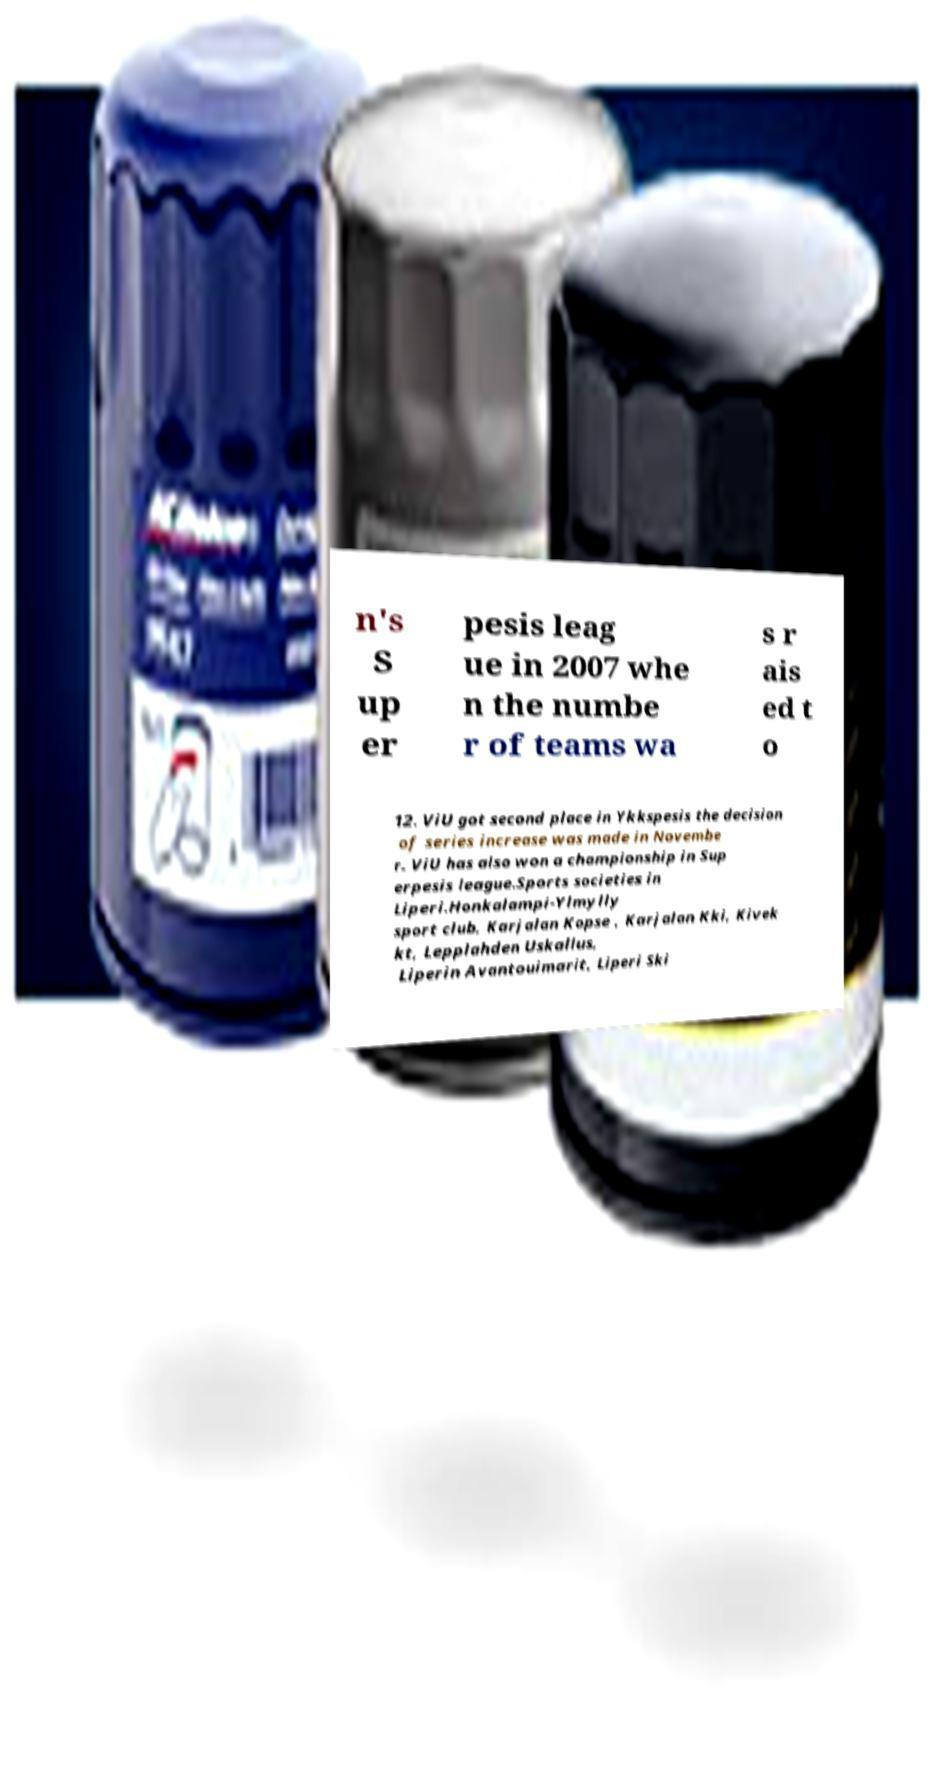Can you accurately transcribe the text from the provided image for me? n's S up er pesis leag ue in 2007 whe n the numbe r of teams wa s r ais ed t o 12. ViU got second place in Ykkspesis the decision of series increase was made in Novembe r. ViU has also won a championship in Sup erpesis league.Sports societies in Liperi.Honkalampi-Ylmylly sport club, Karjalan Kopse , Karjalan Kki, Kivek kt, Lepplahden Uskallus, Liperin Avantouimarit, Liperi Ski 